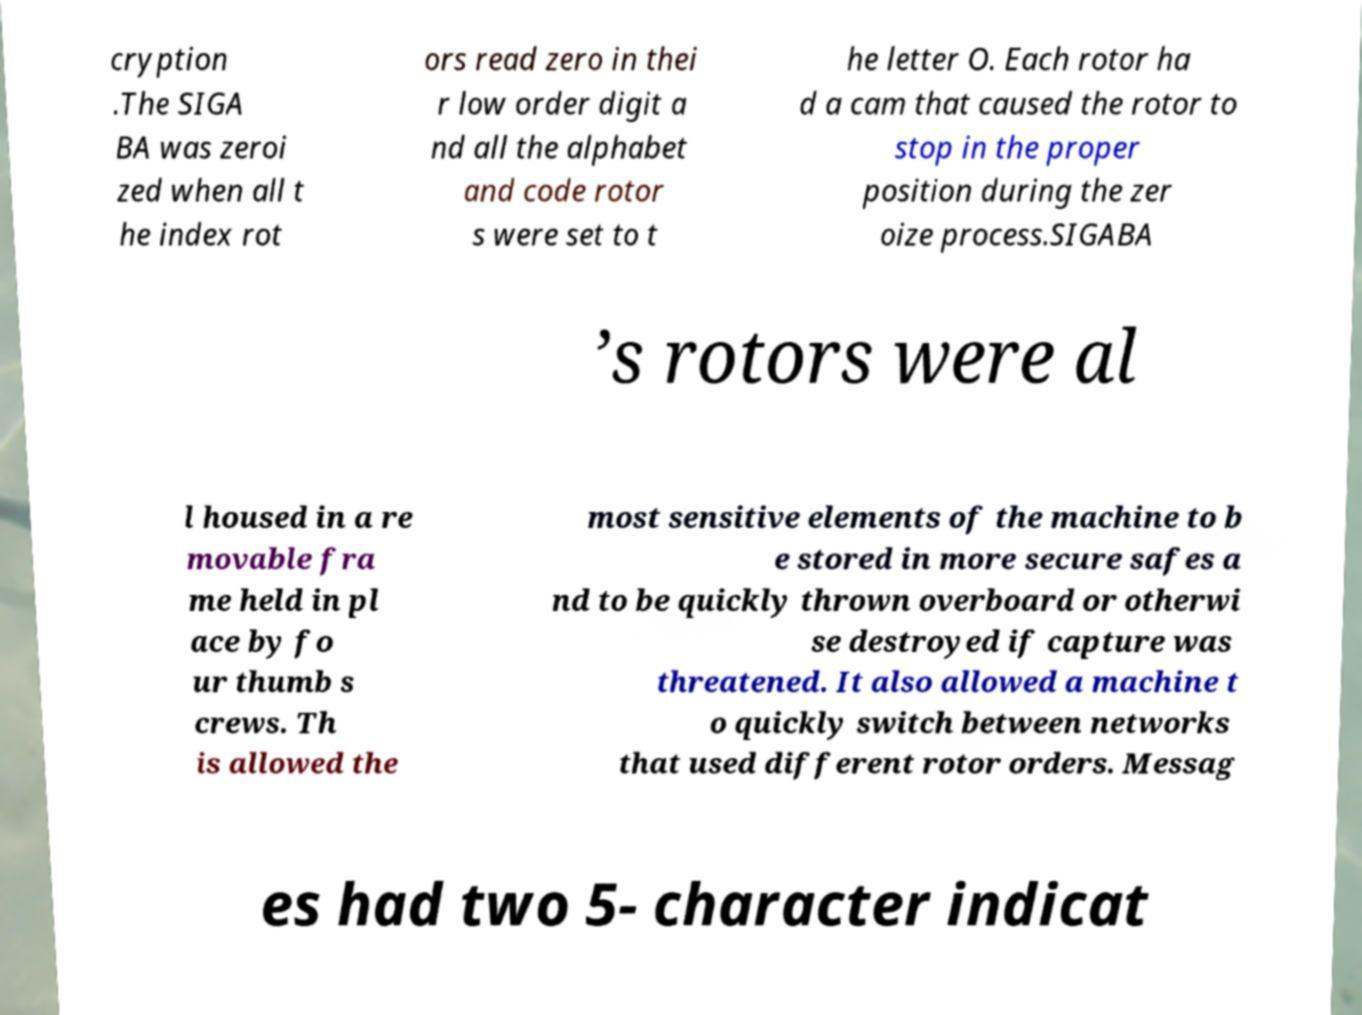There's text embedded in this image that I need extracted. Can you transcribe it verbatim? cryption .The SIGA BA was zeroi zed when all t he index rot ors read zero in thei r low order digit a nd all the alphabet and code rotor s were set to t he letter O. Each rotor ha d a cam that caused the rotor to stop in the proper position during the zer oize process.SIGABA ’s rotors were al l housed in a re movable fra me held in pl ace by fo ur thumb s crews. Th is allowed the most sensitive elements of the machine to b e stored in more secure safes a nd to be quickly thrown overboard or otherwi se destroyed if capture was threatened. It also allowed a machine t o quickly switch between networks that used different rotor orders. Messag es had two 5- character indicat 